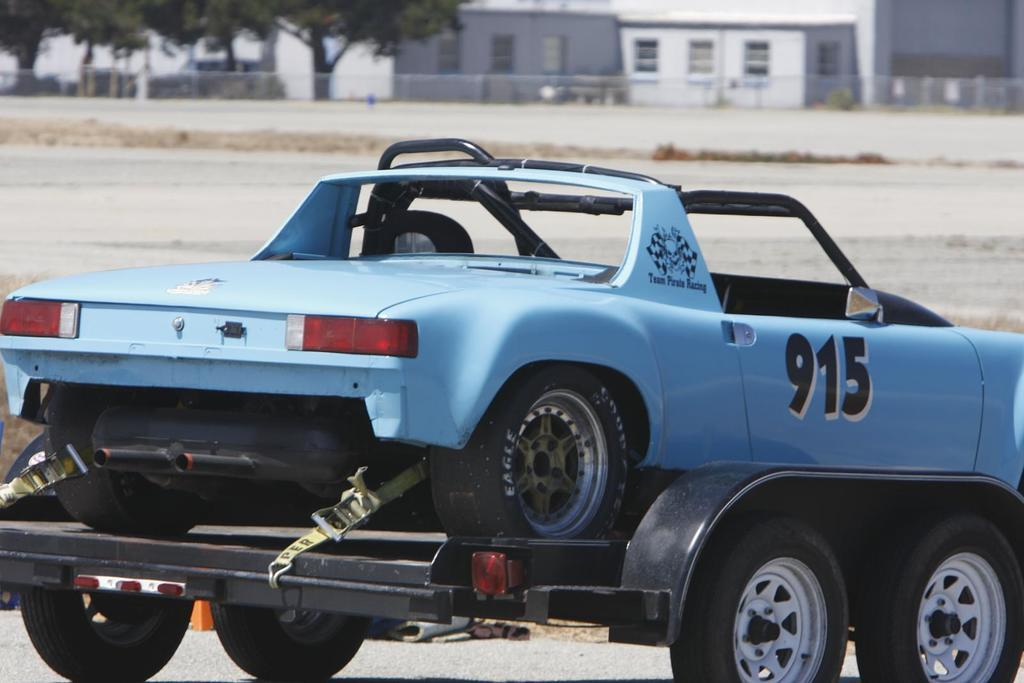What is the main subject of the image? There is a car in the image. How is the car being transported in the image? The car is on a vehicle (possibly a trailer or a truck). What type of surface can be seen in the image? There is ground visible in the image. What can be seen in the distance in the image? There are buildings in the background of the image. What type of vegetation is present in the image? There are trees in the image. What type of barrier is visible in the image? There is a metal grill fence in the image. What type of soup can be seen being poured into the car in the image? There is no soup present in the image, and no liquid is being poured into the car. 